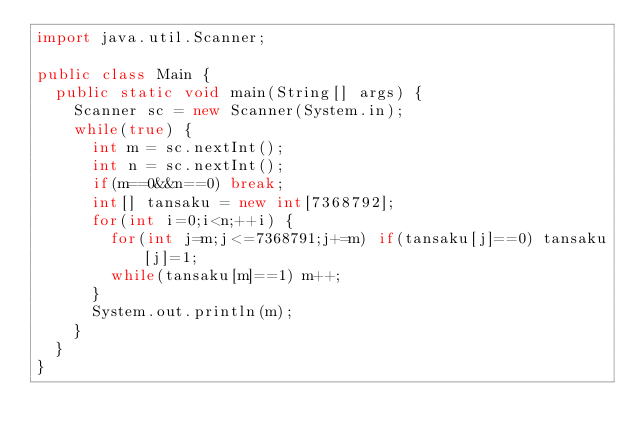<code> <loc_0><loc_0><loc_500><loc_500><_Java_>import java.util.Scanner;

public class Main {
	public static void main(String[] args) {
		Scanner sc = new Scanner(System.in);
		while(true) {
			int m = sc.nextInt();
			int n = sc.nextInt();
			if(m==0&&n==0) break;
			int[] tansaku = new int[7368792];
			for(int i=0;i<n;++i) {
				for(int j=m;j<=7368791;j+=m) if(tansaku[j]==0) tansaku[j]=1;
				while(tansaku[m]==1) m++;
			}
			System.out.println(m);
		}
	}
}

</code> 